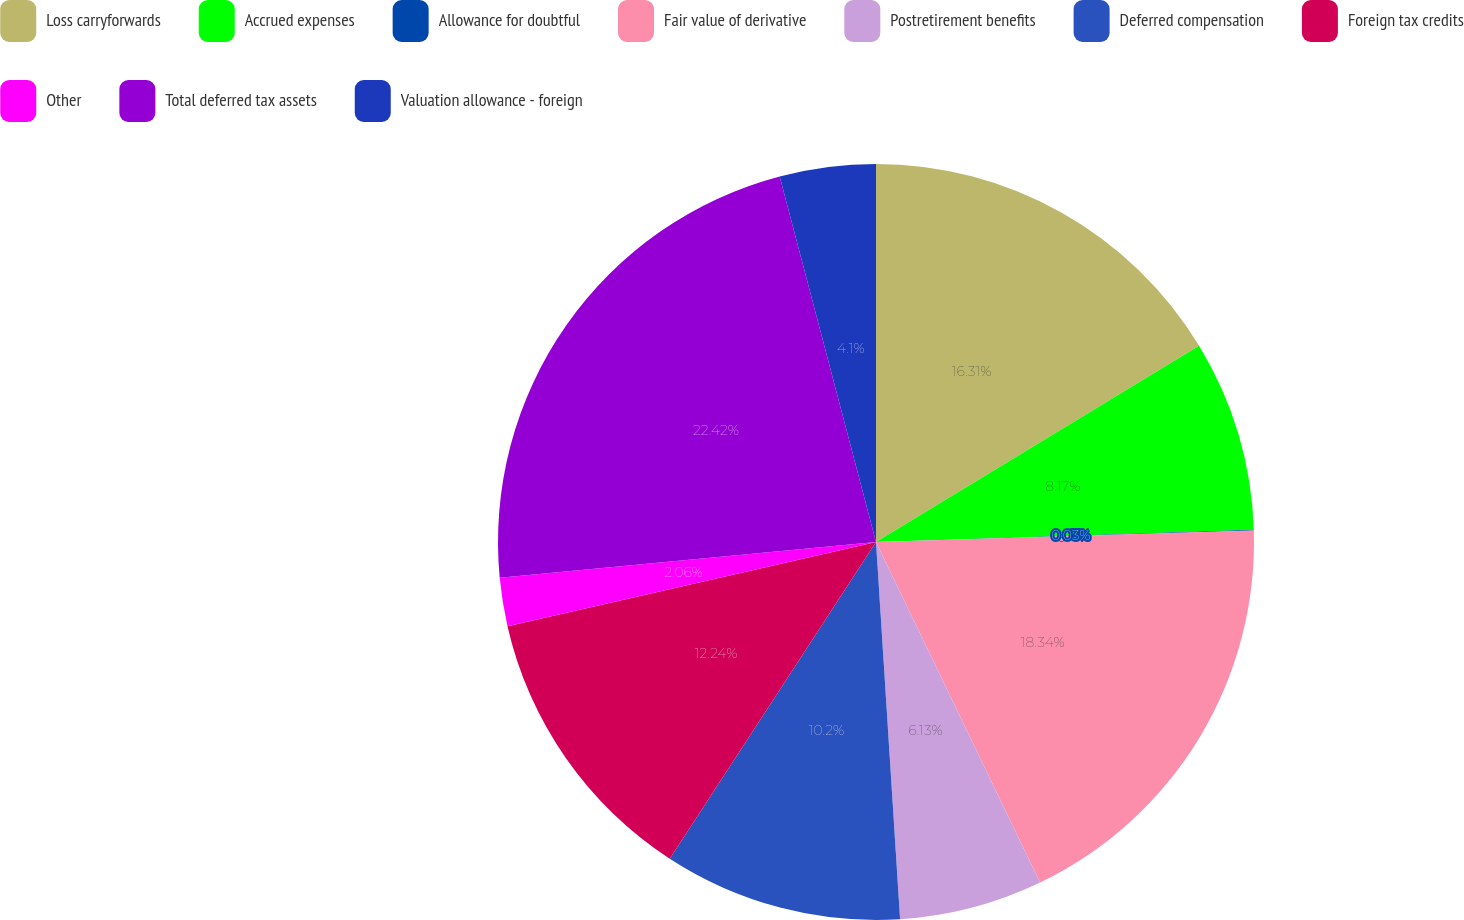Convert chart. <chart><loc_0><loc_0><loc_500><loc_500><pie_chart><fcel>Loss carryforwards<fcel>Accrued expenses<fcel>Allowance for doubtful<fcel>Fair value of derivative<fcel>Postretirement benefits<fcel>Deferred compensation<fcel>Foreign tax credits<fcel>Other<fcel>Total deferred tax assets<fcel>Valuation allowance - foreign<nl><fcel>16.31%<fcel>8.17%<fcel>0.03%<fcel>18.34%<fcel>6.13%<fcel>10.2%<fcel>12.24%<fcel>2.06%<fcel>22.41%<fcel>4.1%<nl></chart> 